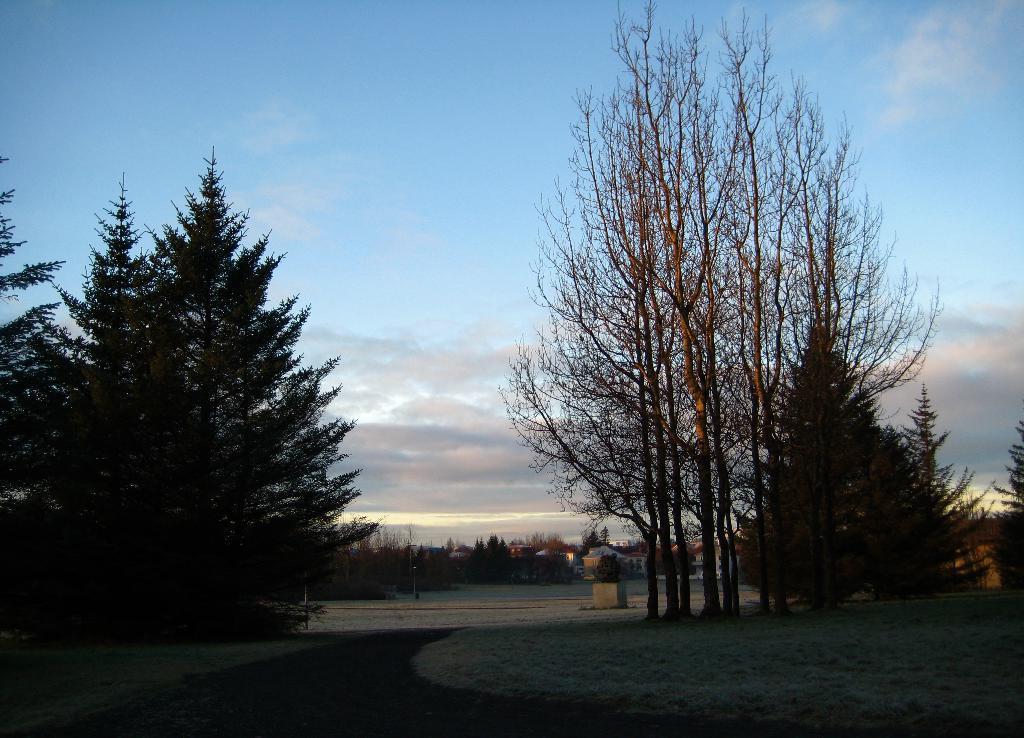How would you summarize this image in a sentence or two? In this image I can see a empty road, beside that there are so many trees and building. 